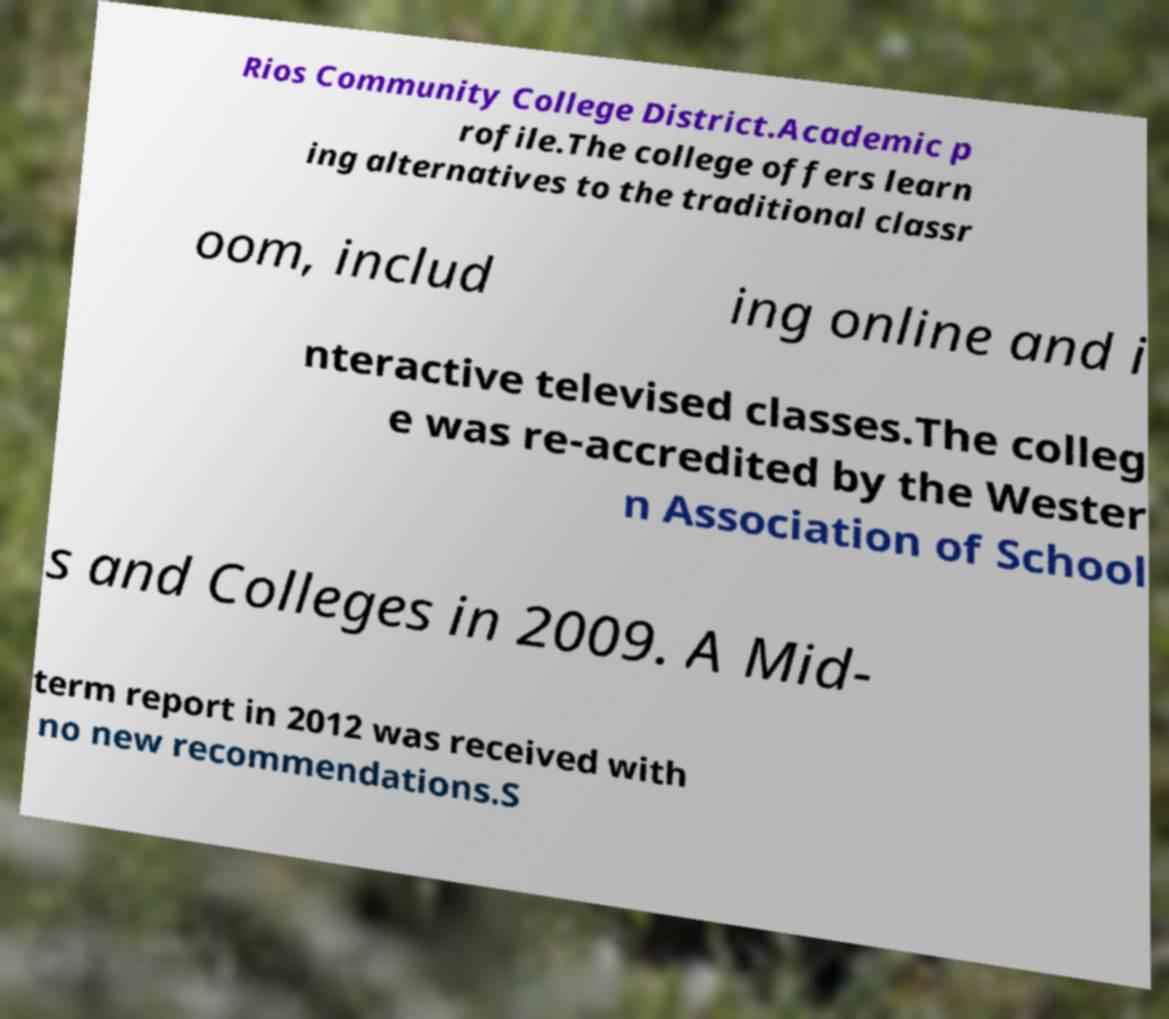There's text embedded in this image that I need extracted. Can you transcribe it verbatim? Rios Community College District.Academic p rofile.The college offers learn ing alternatives to the traditional classr oom, includ ing online and i nteractive televised classes.The colleg e was re-accredited by the Wester n Association of School s and Colleges in 2009. A Mid- term report in 2012 was received with no new recommendations.S 